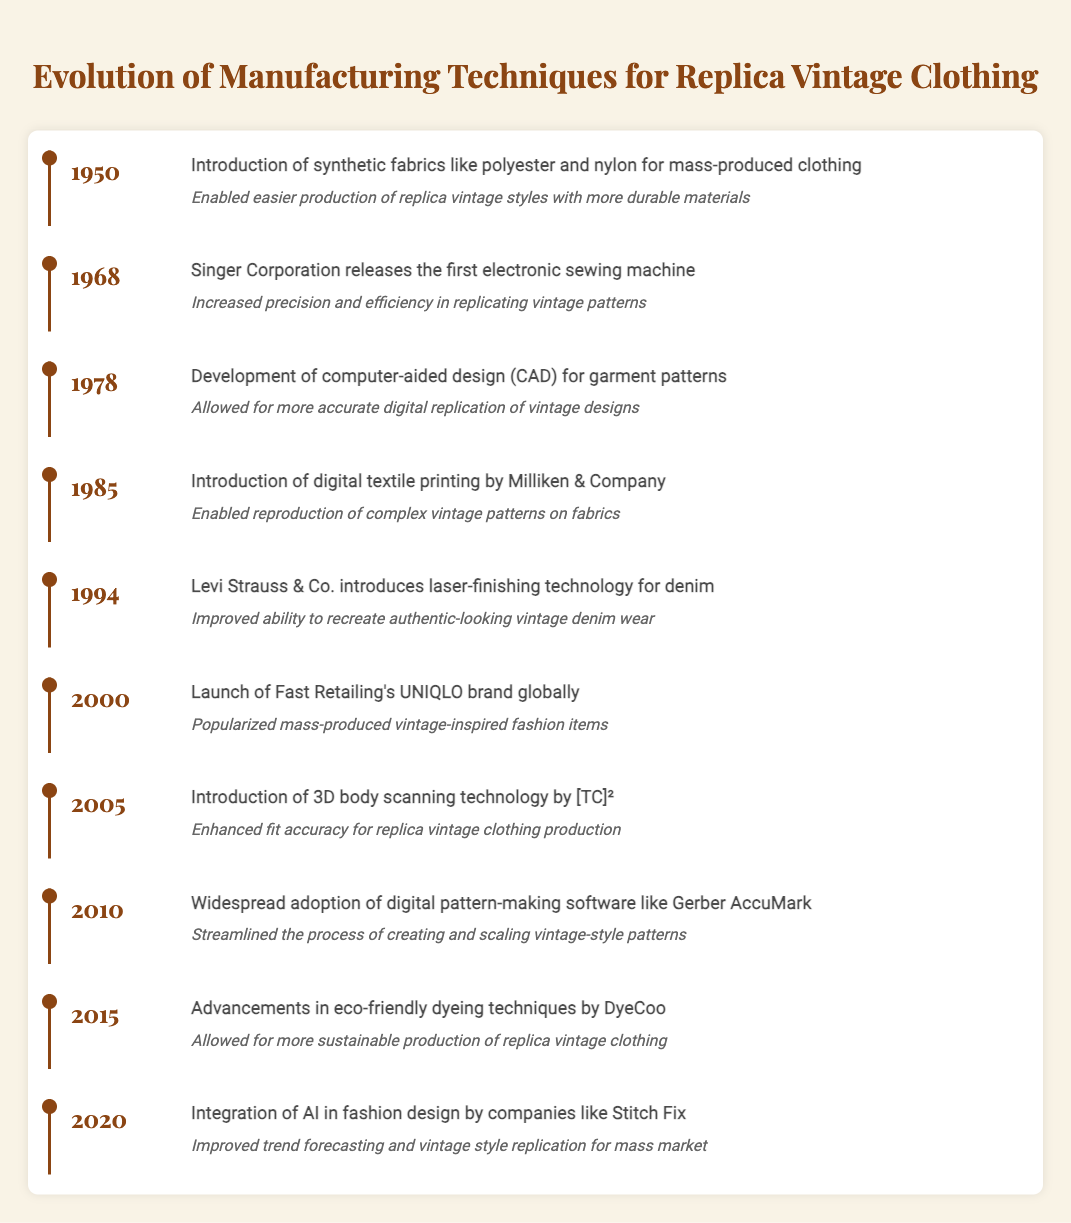What manufacturing technique was introduced in 1968? Referring to the timeline, the event listed in 1968 is the release of the first electronic sewing machine by Singer Corporation.
Answer: Introduction of electronic sewing machine What year did the introduction of digital textile printing occur? According to the timeline, digital textile printing was introduced in 1985.
Answer: 1985 True or False: The use of eco-friendly dyeing techniques was advanced in 2015. The timeline states that advancements in eco-friendly dyeing techniques by DyeCoo occurred in 2015, making this statement true.
Answer: True What event improved the accuracy of fit for replica vintage clothing production? The introduction of 3D body scanning technology by [TC]² in 2005 enhanced the fit accuracy for replica vintage clothing production.
Answer: Introduction of 3D body scanning technology Which year saw the introduction of computer-aided design for garment patterns? What impact did it have? The development of computer-aided design (CAD) for garment patterns occurred in 1978, allowing for more accurate digital replication of vintage designs.
Answer: 1978; Allowed for more accurate digital replication of vintage designs What is the timeline gap between the launch of UNIQLO and the advancement in eco-friendly dyeing techniques? The launch of Fast Retailing's UNIQLO brand happened in 2000, and the advancements in eco-friendly dyeing techniques occurred in 2015. The gap is 15 years.
Answer: 15 years What was the overall impact of introducing synthetic fabrics in 1950 on vintage styles? The introduction of synthetic fabrics enabled easier production of replica vintage styles using more durable materials, as noted in the impact section of that year.
Answer: Enabled easier production with durable materials In which years were significant technological advancements introduced (CAD or digital textile printing)? Significant advancements included CAD in 1978 and digital textile printing in 1985. Therefore, both years correspond to significant technological improvements.
Answer: 1978 and 1985 What is the trend in the timeline regarding advancements in manufacturing techniques from 1950 to 2020? The timeline shows a consistent trend of technological advancements over the decades, enhancing the precision, efficiency, and sustainability of manufacturing techniques for vintage replica clothing.
Answer: Consistent trend of advancements 